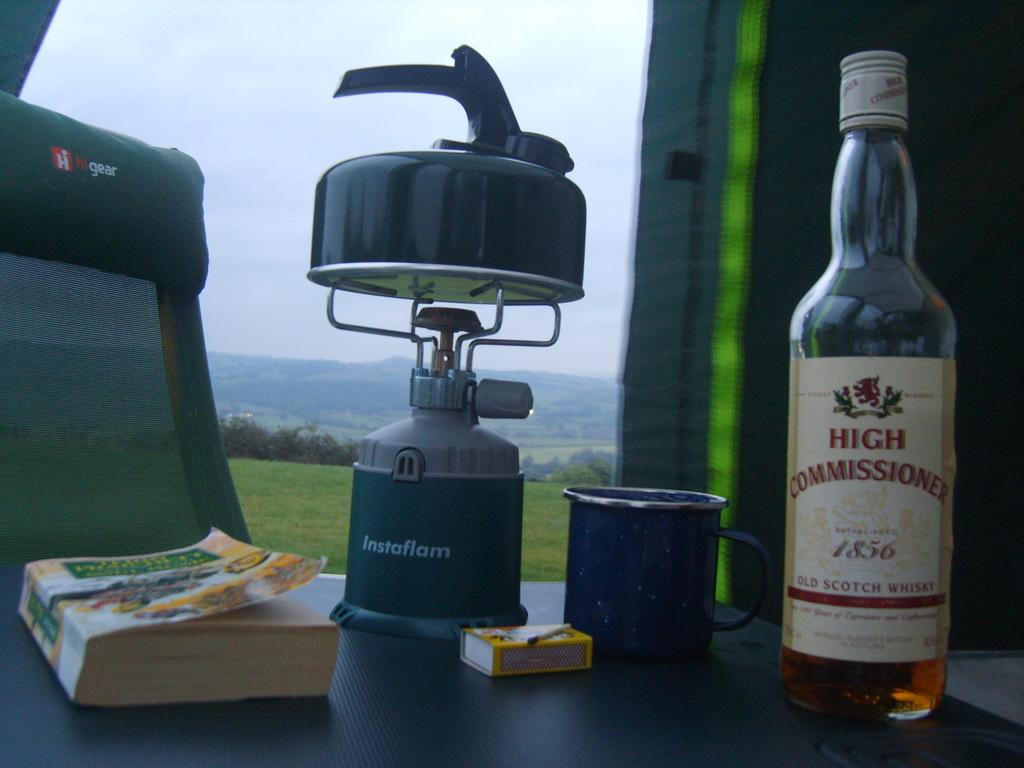<image>
Describe the image concisely. A bottle of High Commissioner Scotch is next to a mug on a table. 